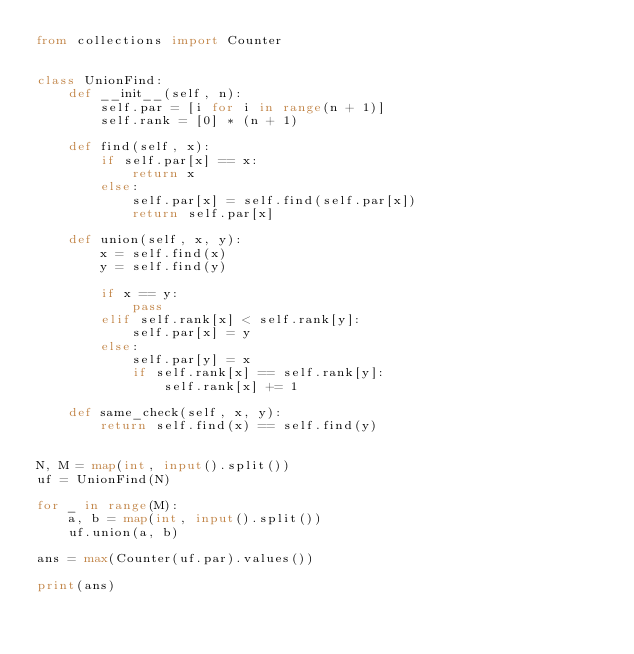Convert code to text. <code><loc_0><loc_0><loc_500><loc_500><_Python_>from collections import Counter


class UnionFind:
    def __init__(self, n):
        self.par = [i for i in range(n + 1)]
        self.rank = [0] * (n + 1)

    def find(self, x):
        if self.par[x] == x:
            return x
        else:
            self.par[x] = self.find(self.par[x])
            return self.par[x]

    def union(self, x, y):
        x = self.find(x)
        y = self.find(y)

        if x == y:
            pass
        elif self.rank[x] < self.rank[y]:
            self.par[x] = y
        else:
            self.par[y] = x
            if self.rank[x] == self.rank[y]:
                self.rank[x] += 1

    def same_check(self, x, y):
        return self.find(x) == self.find(y)


N, M = map(int, input().split())
uf = UnionFind(N)

for _ in range(M):
    a, b = map(int, input().split())
    uf.union(a, b)

ans = max(Counter(uf.par).values())

print(ans)</code> 